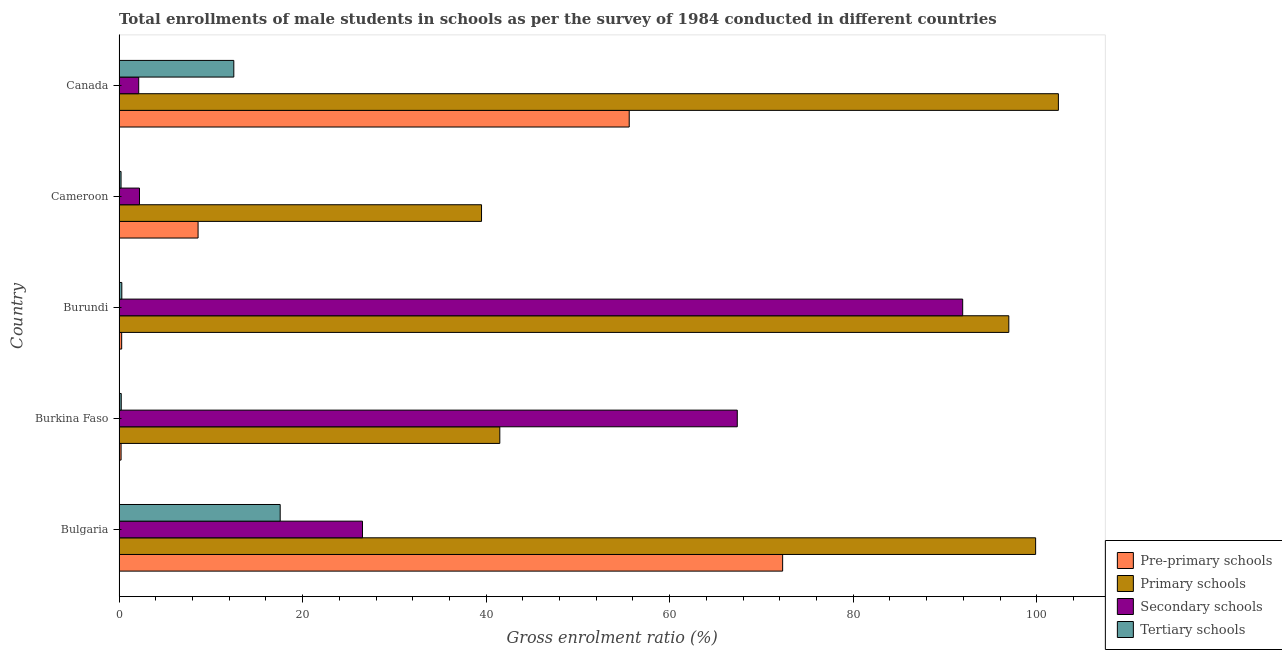How many different coloured bars are there?
Your answer should be very brief. 4. Are the number of bars per tick equal to the number of legend labels?
Provide a short and direct response. Yes. How many bars are there on the 5th tick from the top?
Offer a very short reply. 4. How many bars are there on the 1st tick from the bottom?
Your answer should be compact. 4. What is the label of the 5th group of bars from the top?
Keep it short and to the point. Bulgaria. In how many cases, is the number of bars for a given country not equal to the number of legend labels?
Ensure brevity in your answer.  0. What is the gross enrolment ratio(male) in primary schools in Canada?
Make the answer very short. 102.36. Across all countries, what is the maximum gross enrolment ratio(male) in primary schools?
Make the answer very short. 102.36. Across all countries, what is the minimum gross enrolment ratio(male) in secondary schools?
Offer a terse response. 2.14. In which country was the gross enrolment ratio(male) in pre-primary schools minimum?
Your answer should be very brief. Burkina Faso. What is the total gross enrolment ratio(male) in secondary schools in the graph?
Offer a very short reply. 190.19. What is the difference between the gross enrolment ratio(male) in tertiary schools in Burkina Faso and that in Burundi?
Your answer should be very brief. -0.06. What is the difference between the gross enrolment ratio(male) in pre-primary schools in Burundi and the gross enrolment ratio(male) in primary schools in Burkina Faso?
Keep it short and to the point. -41.2. What is the average gross enrolment ratio(male) in secondary schools per country?
Make the answer very short. 38.04. What is the difference between the gross enrolment ratio(male) in primary schools and gross enrolment ratio(male) in pre-primary schools in Bulgaria?
Make the answer very short. 27.57. In how many countries, is the gross enrolment ratio(male) in tertiary schools greater than 24 %?
Make the answer very short. 0. What is the ratio of the gross enrolment ratio(male) in tertiary schools in Bulgaria to that in Cameroon?
Your answer should be compact. 80.86. What is the difference between the highest and the second highest gross enrolment ratio(male) in tertiary schools?
Provide a succinct answer. 5.05. What is the difference between the highest and the lowest gross enrolment ratio(male) in primary schools?
Your answer should be compact. 62.86. Is the sum of the gross enrolment ratio(male) in pre-primary schools in Bulgaria and Canada greater than the maximum gross enrolment ratio(male) in secondary schools across all countries?
Your answer should be compact. Yes. Is it the case that in every country, the sum of the gross enrolment ratio(male) in tertiary schools and gross enrolment ratio(male) in secondary schools is greater than the sum of gross enrolment ratio(male) in pre-primary schools and gross enrolment ratio(male) in primary schools?
Keep it short and to the point. No. What does the 3rd bar from the top in Cameroon represents?
Ensure brevity in your answer.  Primary schools. What does the 3rd bar from the bottom in Burundi represents?
Provide a short and direct response. Secondary schools. Is it the case that in every country, the sum of the gross enrolment ratio(male) in pre-primary schools and gross enrolment ratio(male) in primary schools is greater than the gross enrolment ratio(male) in secondary schools?
Offer a very short reply. No. How many bars are there?
Make the answer very short. 20. How many countries are there in the graph?
Keep it short and to the point. 5. Are the values on the major ticks of X-axis written in scientific E-notation?
Give a very brief answer. No. How are the legend labels stacked?
Provide a short and direct response. Vertical. What is the title of the graph?
Offer a very short reply. Total enrollments of male students in schools as per the survey of 1984 conducted in different countries. Does "Sweden" appear as one of the legend labels in the graph?
Offer a very short reply. No. What is the label or title of the Y-axis?
Keep it short and to the point. Country. What is the Gross enrolment ratio (%) in Pre-primary schools in Bulgaria?
Your answer should be very brief. 72.31. What is the Gross enrolment ratio (%) in Primary schools in Bulgaria?
Offer a very short reply. 99.88. What is the Gross enrolment ratio (%) in Secondary schools in Bulgaria?
Give a very brief answer. 26.53. What is the Gross enrolment ratio (%) of Tertiary schools in Bulgaria?
Offer a very short reply. 17.56. What is the Gross enrolment ratio (%) in Pre-primary schools in Burkina Faso?
Give a very brief answer. 0.22. What is the Gross enrolment ratio (%) in Primary schools in Burkina Faso?
Offer a terse response. 41.49. What is the Gross enrolment ratio (%) of Secondary schools in Burkina Faso?
Your response must be concise. 67.37. What is the Gross enrolment ratio (%) of Tertiary schools in Burkina Faso?
Keep it short and to the point. 0.24. What is the Gross enrolment ratio (%) in Pre-primary schools in Burundi?
Give a very brief answer. 0.28. What is the Gross enrolment ratio (%) in Primary schools in Burundi?
Ensure brevity in your answer.  96.95. What is the Gross enrolment ratio (%) of Secondary schools in Burundi?
Offer a very short reply. 91.93. What is the Gross enrolment ratio (%) in Tertiary schools in Burundi?
Your response must be concise. 0.3. What is the Gross enrolment ratio (%) of Pre-primary schools in Cameroon?
Offer a very short reply. 8.61. What is the Gross enrolment ratio (%) in Primary schools in Cameroon?
Keep it short and to the point. 39.5. What is the Gross enrolment ratio (%) in Secondary schools in Cameroon?
Offer a terse response. 2.23. What is the Gross enrolment ratio (%) in Tertiary schools in Cameroon?
Your answer should be very brief. 0.22. What is the Gross enrolment ratio (%) of Pre-primary schools in Canada?
Your response must be concise. 55.59. What is the Gross enrolment ratio (%) in Primary schools in Canada?
Your response must be concise. 102.36. What is the Gross enrolment ratio (%) in Secondary schools in Canada?
Offer a terse response. 2.14. What is the Gross enrolment ratio (%) in Tertiary schools in Canada?
Your response must be concise. 12.51. Across all countries, what is the maximum Gross enrolment ratio (%) in Pre-primary schools?
Your answer should be very brief. 72.31. Across all countries, what is the maximum Gross enrolment ratio (%) in Primary schools?
Give a very brief answer. 102.36. Across all countries, what is the maximum Gross enrolment ratio (%) of Secondary schools?
Your answer should be compact. 91.93. Across all countries, what is the maximum Gross enrolment ratio (%) of Tertiary schools?
Offer a very short reply. 17.56. Across all countries, what is the minimum Gross enrolment ratio (%) in Pre-primary schools?
Make the answer very short. 0.22. Across all countries, what is the minimum Gross enrolment ratio (%) in Primary schools?
Keep it short and to the point. 39.5. Across all countries, what is the minimum Gross enrolment ratio (%) of Secondary schools?
Give a very brief answer. 2.14. Across all countries, what is the minimum Gross enrolment ratio (%) in Tertiary schools?
Your answer should be compact. 0.22. What is the total Gross enrolment ratio (%) in Pre-primary schools in the graph?
Keep it short and to the point. 137.02. What is the total Gross enrolment ratio (%) of Primary schools in the graph?
Provide a short and direct response. 380.18. What is the total Gross enrolment ratio (%) of Secondary schools in the graph?
Provide a short and direct response. 190.19. What is the total Gross enrolment ratio (%) of Tertiary schools in the graph?
Ensure brevity in your answer.  30.82. What is the difference between the Gross enrolment ratio (%) of Pre-primary schools in Bulgaria and that in Burkina Faso?
Your response must be concise. 72.09. What is the difference between the Gross enrolment ratio (%) in Primary schools in Bulgaria and that in Burkina Faso?
Provide a short and direct response. 58.39. What is the difference between the Gross enrolment ratio (%) of Secondary schools in Bulgaria and that in Burkina Faso?
Your answer should be compact. -40.84. What is the difference between the Gross enrolment ratio (%) in Tertiary schools in Bulgaria and that in Burkina Faso?
Make the answer very short. 17.32. What is the difference between the Gross enrolment ratio (%) of Pre-primary schools in Bulgaria and that in Burundi?
Your answer should be compact. 72.02. What is the difference between the Gross enrolment ratio (%) of Primary schools in Bulgaria and that in Burundi?
Ensure brevity in your answer.  2.92. What is the difference between the Gross enrolment ratio (%) of Secondary schools in Bulgaria and that in Burundi?
Keep it short and to the point. -65.4. What is the difference between the Gross enrolment ratio (%) of Tertiary schools in Bulgaria and that in Burundi?
Your answer should be compact. 17.26. What is the difference between the Gross enrolment ratio (%) in Pre-primary schools in Bulgaria and that in Cameroon?
Give a very brief answer. 63.7. What is the difference between the Gross enrolment ratio (%) of Primary schools in Bulgaria and that in Cameroon?
Offer a very short reply. 60.38. What is the difference between the Gross enrolment ratio (%) of Secondary schools in Bulgaria and that in Cameroon?
Your answer should be compact. 24.3. What is the difference between the Gross enrolment ratio (%) in Tertiary schools in Bulgaria and that in Cameroon?
Make the answer very short. 17.34. What is the difference between the Gross enrolment ratio (%) in Pre-primary schools in Bulgaria and that in Canada?
Your response must be concise. 16.72. What is the difference between the Gross enrolment ratio (%) of Primary schools in Bulgaria and that in Canada?
Ensure brevity in your answer.  -2.48. What is the difference between the Gross enrolment ratio (%) in Secondary schools in Bulgaria and that in Canada?
Give a very brief answer. 24.38. What is the difference between the Gross enrolment ratio (%) in Tertiary schools in Bulgaria and that in Canada?
Give a very brief answer. 5.05. What is the difference between the Gross enrolment ratio (%) in Pre-primary schools in Burkina Faso and that in Burundi?
Give a very brief answer. -0.06. What is the difference between the Gross enrolment ratio (%) of Primary schools in Burkina Faso and that in Burundi?
Provide a succinct answer. -55.46. What is the difference between the Gross enrolment ratio (%) of Secondary schools in Burkina Faso and that in Burundi?
Ensure brevity in your answer.  -24.56. What is the difference between the Gross enrolment ratio (%) in Tertiary schools in Burkina Faso and that in Burundi?
Ensure brevity in your answer.  -0.06. What is the difference between the Gross enrolment ratio (%) of Pre-primary schools in Burkina Faso and that in Cameroon?
Give a very brief answer. -8.39. What is the difference between the Gross enrolment ratio (%) in Primary schools in Burkina Faso and that in Cameroon?
Provide a short and direct response. 1.99. What is the difference between the Gross enrolment ratio (%) of Secondary schools in Burkina Faso and that in Cameroon?
Keep it short and to the point. 65.14. What is the difference between the Gross enrolment ratio (%) in Tertiary schools in Burkina Faso and that in Cameroon?
Your response must be concise. 0.02. What is the difference between the Gross enrolment ratio (%) of Pre-primary schools in Burkina Faso and that in Canada?
Offer a very short reply. -55.37. What is the difference between the Gross enrolment ratio (%) in Primary schools in Burkina Faso and that in Canada?
Keep it short and to the point. -60.87. What is the difference between the Gross enrolment ratio (%) in Secondary schools in Burkina Faso and that in Canada?
Your response must be concise. 65.22. What is the difference between the Gross enrolment ratio (%) of Tertiary schools in Burkina Faso and that in Canada?
Give a very brief answer. -12.27. What is the difference between the Gross enrolment ratio (%) in Pre-primary schools in Burundi and that in Cameroon?
Make the answer very short. -8.33. What is the difference between the Gross enrolment ratio (%) in Primary schools in Burundi and that in Cameroon?
Your answer should be very brief. 57.45. What is the difference between the Gross enrolment ratio (%) in Secondary schools in Burundi and that in Cameroon?
Give a very brief answer. 89.7. What is the difference between the Gross enrolment ratio (%) in Tertiary schools in Burundi and that in Cameroon?
Ensure brevity in your answer.  0.08. What is the difference between the Gross enrolment ratio (%) of Pre-primary schools in Burundi and that in Canada?
Give a very brief answer. -55.31. What is the difference between the Gross enrolment ratio (%) in Primary schools in Burundi and that in Canada?
Provide a short and direct response. -5.4. What is the difference between the Gross enrolment ratio (%) of Secondary schools in Burundi and that in Canada?
Provide a succinct answer. 89.79. What is the difference between the Gross enrolment ratio (%) in Tertiary schools in Burundi and that in Canada?
Make the answer very short. -12.2. What is the difference between the Gross enrolment ratio (%) of Pre-primary schools in Cameroon and that in Canada?
Provide a short and direct response. -46.98. What is the difference between the Gross enrolment ratio (%) of Primary schools in Cameroon and that in Canada?
Ensure brevity in your answer.  -62.86. What is the difference between the Gross enrolment ratio (%) of Secondary schools in Cameroon and that in Canada?
Give a very brief answer. 0.08. What is the difference between the Gross enrolment ratio (%) in Tertiary schools in Cameroon and that in Canada?
Make the answer very short. -12.29. What is the difference between the Gross enrolment ratio (%) of Pre-primary schools in Bulgaria and the Gross enrolment ratio (%) of Primary schools in Burkina Faso?
Provide a succinct answer. 30.82. What is the difference between the Gross enrolment ratio (%) in Pre-primary schools in Bulgaria and the Gross enrolment ratio (%) in Secondary schools in Burkina Faso?
Ensure brevity in your answer.  4.94. What is the difference between the Gross enrolment ratio (%) of Pre-primary schools in Bulgaria and the Gross enrolment ratio (%) of Tertiary schools in Burkina Faso?
Offer a very short reply. 72.07. What is the difference between the Gross enrolment ratio (%) of Primary schools in Bulgaria and the Gross enrolment ratio (%) of Secondary schools in Burkina Faso?
Offer a terse response. 32.51. What is the difference between the Gross enrolment ratio (%) in Primary schools in Bulgaria and the Gross enrolment ratio (%) in Tertiary schools in Burkina Faso?
Ensure brevity in your answer.  99.64. What is the difference between the Gross enrolment ratio (%) in Secondary schools in Bulgaria and the Gross enrolment ratio (%) in Tertiary schools in Burkina Faso?
Provide a short and direct response. 26.29. What is the difference between the Gross enrolment ratio (%) of Pre-primary schools in Bulgaria and the Gross enrolment ratio (%) of Primary schools in Burundi?
Your response must be concise. -24.64. What is the difference between the Gross enrolment ratio (%) in Pre-primary schools in Bulgaria and the Gross enrolment ratio (%) in Secondary schools in Burundi?
Offer a very short reply. -19.62. What is the difference between the Gross enrolment ratio (%) of Pre-primary schools in Bulgaria and the Gross enrolment ratio (%) of Tertiary schools in Burundi?
Your response must be concise. 72.01. What is the difference between the Gross enrolment ratio (%) in Primary schools in Bulgaria and the Gross enrolment ratio (%) in Secondary schools in Burundi?
Offer a very short reply. 7.95. What is the difference between the Gross enrolment ratio (%) of Primary schools in Bulgaria and the Gross enrolment ratio (%) of Tertiary schools in Burundi?
Provide a succinct answer. 99.58. What is the difference between the Gross enrolment ratio (%) of Secondary schools in Bulgaria and the Gross enrolment ratio (%) of Tertiary schools in Burundi?
Your answer should be very brief. 26.22. What is the difference between the Gross enrolment ratio (%) of Pre-primary schools in Bulgaria and the Gross enrolment ratio (%) of Primary schools in Cameroon?
Make the answer very short. 32.81. What is the difference between the Gross enrolment ratio (%) in Pre-primary schools in Bulgaria and the Gross enrolment ratio (%) in Secondary schools in Cameroon?
Give a very brief answer. 70.08. What is the difference between the Gross enrolment ratio (%) of Pre-primary schools in Bulgaria and the Gross enrolment ratio (%) of Tertiary schools in Cameroon?
Ensure brevity in your answer.  72.09. What is the difference between the Gross enrolment ratio (%) of Primary schools in Bulgaria and the Gross enrolment ratio (%) of Secondary schools in Cameroon?
Ensure brevity in your answer.  97.65. What is the difference between the Gross enrolment ratio (%) of Primary schools in Bulgaria and the Gross enrolment ratio (%) of Tertiary schools in Cameroon?
Give a very brief answer. 99.66. What is the difference between the Gross enrolment ratio (%) in Secondary schools in Bulgaria and the Gross enrolment ratio (%) in Tertiary schools in Cameroon?
Your answer should be very brief. 26.31. What is the difference between the Gross enrolment ratio (%) in Pre-primary schools in Bulgaria and the Gross enrolment ratio (%) in Primary schools in Canada?
Provide a short and direct response. -30.05. What is the difference between the Gross enrolment ratio (%) in Pre-primary schools in Bulgaria and the Gross enrolment ratio (%) in Secondary schools in Canada?
Offer a terse response. 70.17. What is the difference between the Gross enrolment ratio (%) in Pre-primary schools in Bulgaria and the Gross enrolment ratio (%) in Tertiary schools in Canada?
Make the answer very short. 59.8. What is the difference between the Gross enrolment ratio (%) of Primary schools in Bulgaria and the Gross enrolment ratio (%) of Secondary schools in Canada?
Make the answer very short. 97.73. What is the difference between the Gross enrolment ratio (%) in Primary schools in Bulgaria and the Gross enrolment ratio (%) in Tertiary schools in Canada?
Your answer should be compact. 87.37. What is the difference between the Gross enrolment ratio (%) of Secondary schools in Bulgaria and the Gross enrolment ratio (%) of Tertiary schools in Canada?
Your answer should be compact. 14.02. What is the difference between the Gross enrolment ratio (%) of Pre-primary schools in Burkina Faso and the Gross enrolment ratio (%) of Primary schools in Burundi?
Provide a succinct answer. -96.73. What is the difference between the Gross enrolment ratio (%) of Pre-primary schools in Burkina Faso and the Gross enrolment ratio (%) of Secondary schools in Burundi?
Make the answer very short. -91.71. What is the difference between the Gross enrolment ratio (%) in Pre-primary schools in Burkina Faso and the Gross enrolment ratio (%) in Tertiary schools in Burundi?
Keep it short and to the point. -0.08. What is the difference between the Gross enrolment ratio (%) in Primary schools in Burkina Faso and the Gross enrolment ratio (%) in Secondary schools in Burundi?
Offer a terse response. -50.44. What is the difference between the Gross enrolment ratio (%) in Primary schools in Burkina Faso and the Gross enrolment ratio (%) in Tertiary schools in Burundi?
Ensure brevity in your answer.  41.19. What is the difference between the Gross enrolment ratio (%) in Secondary schools in Burkina Faso and the Gross enrolment ratio (%) in Tertiary schools in Burundi?
Offer a very short reply. 67.07. What is the difference between the Gross enrolment ratio (%) in Pre-primary schools in Burkina Faso and the Gross enrolment ratio (%) in Primary schools in Cameroon?
Provide a succinct answer. -39.28. What is the difference between the Gross enrolment ratio (%) of Pre-primary schools in Burkina Faso and the Gross enrolment ratio (%) of Secondary schools in Cameroon?
Your answer should be very brief. -2.01. What is the difference between the Gross enrolment ratio (%) of Pre-primary schools in Burkina Faso and the Gross enrolment ratio (%) of Tertiary schools in Cameroon?
Keep it short and to the point. 0. What is the difference between the Gross enrolment ratio (%) of Primary schools in Burkina Faso and the Gross enrolment ratio (%) of Secondary schools in Cameroon?
Ensure brevity in your answer.  39.26. What is the difference between the Gross enrolment ratio (%) in Primary schools in Burkina Faso and the Gross enrolment ratio (%) in Tertiary schools in Cameroon?
Offer a terse response. 41.27. What is the difference between the Gross enrolment ratio (%) of Secondary schools in Burkina Faso and the Gross enrolment ratio (%) of Tertiary schools in Cameroon?
Keep it short and to the point. 67.15. What is the difference between the Gross enrolment ratio (%) of Pre-primary schools in Burkina Faso and the Gross enrolment ratio (%) of Primary schools in Canada?
Ensure brevity in your answer.  -102.14. What is the difference between the Gross enrolment ratio (%) of Pre-primary schools in Burkina Faso and the Gross enrolment ratio (%) of Secondary schools in Canada?
Make the answer very short. -1.92. What is the difference between the Gross enrolment ratio (%) in Pre-primary schools in Burkina Faso and the Gross enrolment ratio (%) in Tertiary schools in Canada?
Your response must be concise. -12.28. What is the difference between the Gross enrolment ratio (%) in Primary schools in Burkina Faso and the Gross enrolment ratio (%) in Secondary schools in Canada?
Provide a succinct answer. 39.35. What is the difference between the Gross enrolment ratio (%) in Primary schools in Burkina Faso and the Gross enrolment ratio (%) in Tertiary schools in Canada?
Keep it short and to the point. 28.98. What is the difference between the Gross enrolment ratio (%) in Secondary schools in Burkina Faso and the Gross enrolment ratio (%) in Tertiary schools in Canada?
Offer a very short reply. 54.86. What is the difference between the Gross enrolment ratio (%) of Pre-primary schools in Burundi and the Gross enrolment ratio (%) of Primary schools in Cameroon?
Your answer should be compact. -39.21. What is the difference between the Gross enrolment ratio (%) in Pre-primary schools in Burundi and the Gross enrolment ratio (%) in Secondary schools in Cameroon?
Keep it short and to the point. -1.94. What is the difference between the Gross enrolment ratio (%) in Pre-primary schools in Burundi and the Gross enrolment ratio (%) in Tertiary schools in Cameroon?
Provide a short and direct response. 0.07. What is the difference between the Gross enrolment ratio (%) in Primary schools in Burundi and the Gross enrolment ratio (%) in Secondary schools in Cameroon?
Give a very brief answer. 94.73. What is the difference between the Gross enrolment ratio (%) of Primary schools in Burundi and the Gross enrolment ratio (%) of Tertiary schools in Cameroon?
Provide a succinct answer. 96.74. What is the difference between the Gross enrolment ratio (%) of Secondary schools in Burundi and the Gross enrolment ratio (%) of Tertiary schools in Cameroon?
Give a very brief answer. 91.71. What is the difference between the Gross enrolment ratio (%) in Pre-primary schools in Burundi and the Gross enrolment ratio (%) in Primary schools in Canada?
Your response must be concise. -102.07. What is the difference between the Gross enrolment ratio (%) in Pre-primary schools in Burundi and the Gross enrolment ratio (%) in Secondary schools in Canada?
Your answer should be very brief. -1.86. What is the difference between the Gross enrolment ratio (%) in Pre-primary schools in Burundi and the Gross enrolment ratio (%) in Tertiary schools in Canada?
Offer a very short reply. -12.22. What is the difference between the Gross enrolment ratio (%) of Primary schools in Burundi and the Gross enrolment ratio (%) of Secondary schools in Canada?
Offer a terse response. 94.81. What is the difference between the Gross enrolment ratio (%) of Primary schools in Burundi and the Gross enrolment ratio (%) of Tertiary schools in Canada?
Provide a succinct answer. 84.45. What is the difference between the Gross enrolment ratio (%) in Secondary schools in Burundi and the Gross enrolment ratio (%) in Tertiary schools in Canada?
Provide a succinct answer. 79.42. What is the difference between the Gross enrolment ratio (%) of Pre-primary schools in Cameroon and the Gross enrolment ratio (%) of Primary schools in Canada?
Ensure brevity in your answer.  -93.75. What is the difference between the Gross enrolment ratio (%) in Pre-primary schools in Cameroon and the Gross enrolment ratio (%) in Secondary schools in Canada?
Your answer should be very brief. 6.47. What is the difference between the Gross enrolment ratio (%) in Pre-primary schools in Cameroon and the Gross enrolment ratio (%) in Tertiary schools in Canada?
Provide a short and direct response. -3.89. What is the difference between the Gross enrolment ratio (%) in Primary schools in Cameroon and the Gross enrolment ratio (%) in Secondary schools in Canada?
Ensure brevity in your answer.  37.36. What is the difference between the Gross enrolment ratio (%) in Primary schools in Cameroon and the Gross enrolment ratio (%) in Tertiary schools in Canada?
Give a very brief answer. 26.99. What is the difference between the Gross enrolment ratio (%) of Secondary schools in Cameroon and the Gross enrolment ratio (%) of Tertiary schools in Canada?
Ensure brevity in your answer.  -10.28. What is the average Gross enrolment ratio (%) in Pre-primary schools per country?
Your answer should be compact. 27.4. What is the average Gross enrolment ratio (%) of Primary schools per country?
Your response must be concise. 76.04. What is the average Gross enrolment ratio (%) in Secondary schools per country?
Your answer should be compact. 38.04. What is the average Gross enrolment ratio (%) in Tertiary schools per country?
Your answer should be very brief. 6.16. What is the difference between the Gross enrolment ratio (%) in Pre-primary schools and Gross enrolment ratio (%) in Primary schools in Bulgaria?
Offer a terse response. -27.57. What is the difference between the Gross enrolment ratio (%) of Pre-primary schools and Gross enrolment ratio (%) of Secondary schools in Bulgaria?
Your answer should be very brief. 45.78. What is the difference between the Gross enrolment ratio (%) in Pre-primary schools and Gross enrolment ratio (%) in Tertiary schools in Bulgaria?
Provide a succinct answer. 54.75. What is the difference between the Gross enrolment ratio (%) in Primary schools and Gross enrolment ratio (%) in Secondary schools in Bulgaria?
Your response must be concise. 73.35. What is the difference between the Gross enrolment ratio (%) in Primary schools and Gross enrolment ratio (%) in Tertiary schools in Bulgaria?
Offer a terse response. 82.32. What is the difference between the Gross enrolment ratio (%) in Secondary schools and Gross enrolment ratio (%) in Tertiary schools in Bulgaria?
Ensure brevity in your answer.  8.97. What is the difference between the Gross enrolment ratio (%) of Pre-primary schools and Gross enrolment ratio (%) of Primary schools in Burkina Faso?
Ensure brevity in your answer.  -41.27. What is the difference between the Gross enrolment ratio (%) in Pre-primary schools and Gross enrolment ratio (%) in Secondary schools in Burkina Faso?
Provide a short and direct response. -67.15. What is the difference between the Gross enrolment ratio (%) in Pre-primary schools and Gross enrolment ratio (%) in Tertiary schools in Burkina Faso?
Provide a short and direct response. -0.02. What is the difference between the Gross enrolment ratio (%) in Primary schools and Gross enrolment ratio (%) in Secondary schools in Burkina Faso?
Offer a very short reply. -25.88. What is the difference between the Gross enrolment ratio (%) of Primary schools and Gross enrolment ratio (%) of Tertiary schools in Burkina Faso?
Provide a succinct answer. 41.25. What is the difference between the Gross enrolment ratio (%) in Secondary schools and Gross enrolment ratio (%) in Tertiary schools in Burkina Faso?
Your answer should be compact. 67.13. What is the difference between the Gross enrolment ratio (%) of Pre-primary schools and Gross enrolment ratio (%) of Primary schools in Burundi?
Give a very brief answer. -96.67. What is the difference between the Gross enrolment ratio (%) in Pre-primary schools and Gross enrolment ratio (%) in Secondary schools in Burundi?
Your answer should be very brief. -91.64. What is the difference between the Gross enrolment ratio (%) of Pre-primary schools and Gross enrolment ratio (%) of Tertiary schools in Burundi?
Your response must be concise. -0.02. What is the difference between the Gross enrolment ratio (%) in Primary schools and Gross enrolment ratio (%) in Secondary schools in Burundi?
Offer a very short reply. 5.02. What is the difference between the Gross enrolment ratio (%) in Primary schools and Gross enrolment ratio (%) in Tertiary schools in Burundi?
Your answer should be very brief. 96.65. What is the difference between the Gross enrolment ratio (%) in Secondary schools and Gross enrolment ratio (%) in Tertiary schools in Burundi?
Offer a very short reply. 91.63. What is the difference between the Gross enrolment ratio (%) in Pre-primary schools and Gross enrolment ratio (%) in Primary schools in Cameroon?
Keep it short and to the point. -30.89. What is the difference between the Gross enrolment ratio (%) of Pre-primary schools and Gross enrolment ratio (%) of Secondary schools in Cameroon?
Offer a terse response. 6.38. What is the difference between the Gross enrolment ratio (%) in Pre-primary schools and Gross enrolment ratio (%) in Tertiary schools in Cameroon?
Your response must be concise. 8.39. What is the difference between the Gross enrolment ratio (%) of Primary schools and Gross enrolment ratio (%) of Secondary schools in Cameroon?
Give a very brief answer. 37.27. What is the difference between the Gross enrolment ratio (%) in Primary schools and Gross enrolment ratio (%) in Tertiary schools in Cameroon?
Your answer should be compact. 39.28. What is the difference between the Gross enrolment ratio (%) in Secondary schools and Gross enrolment ratio (%) in Tertiary schools in Cameroon?
Your answer should be very brief. 2.01. What is the difference between the Gross enrolment ratio (%) in Pre-primary schools and Gross enrolment ratio (%) in Primary schools in Canada?
Make the answer very short. -46.77. What is the difference between the Gross enrolment ratio (%) in Pre-primary schools and Gross enrolment ratio (%) in Secondary schools in Canada?
Offer a terse response. 53.45. What is the difference between the Gross enrolment ratio (%) in Pre-primary schools and Gross enrolment ratio (%) in Tertiary schools in Canada?
Provide a succinct answer. 43.08. What is the difference between the Gross enrolment ratio (%) of Primary schools and Gross enrolment ratio (%) of Secondary schools in Canada?
Your answer should be compact. 100.21. What is the difference between the Gross enrolment ratio (%) of Primary schools and Gross enrolment ratio (%) of Tertiary schools in Canada?
Ensure brevity in your answer.  89.85. What is the difference between the Gross enrolment ratio (%) in Secondary schools and Gross enrolment ratio (%) in Tertiary schools in Canada?
Your answer should be very brief. -10.36. What is the ratio of the Gross enrolment ratio (%) of Pre-primary schools in Bulgaria to that in Burkina Faso?
Provide a short and direct response. 326.59. What is the ratio of the Gross enrolment ratio (%) in Primary schools in Bulgaria to that in Burkina Faso?
Give a very brief answer. 2.41. What is the ratio of the Gross enrolment ratio (%) of Secondary schools in Bulgaria to that in Burkina Faso?
Make the answer very short. 0.39. What is the ratio of the Gross enrolment ratio (%) of Tertiary schools in Bulgaria to that in Burkina Faso?
Make the answer very short. 73.68. What is the ratio of the Gross enrolment ratio (%) of Pre-primary schools in Bulgaria to that in Burundi?
Make the answer very short. 253.74. What is the ratio of the Gross enrolment ratio (%) of Primary schools in Bulgaria to that in Burundi?
Offer a terse response. 1.03. What is the ratio of the Gross enrolment ratio (%) of Secondary schools in Bulgaria to that in Burundi?
Provide a short and direct response. 0.29. What is the ratio of the Gross enrolment ratio (%) in Tertiary schools in Bulgaria to that in Burundi?
Provide a short and direct response. 58.34. What is the ratio of the Gross enrolment ratio (%) in Pre-primary schools in Bulgaria to that in Cameroon?
Your answer should be compact. 8.4. What is the ratio of the Gross enrolment ratio (%) of Primary schools in Bulgaria to that in Cameroon?
Give a very brief answer. 2.53. What is the ratio of the Gross enrolment ratio (%) in Secondary schools in Bulgaria to that in Cameroon?
Provide a short and direct response. 11.91. What is the ratio of the Gross enrolment ratio (%) of Tertiary schools in Bulgaria to that in Cameroon?
Offer a terse response. 80.86. What is the ratio of the Gross enrolment ratio (%) of Pre-primary schools in Bulgaria to that in Canada?
Ensure brevity in your answer.  1.3. What is the ratio of the Gross enrolment ratio (%) in Primary schools in Bulgaria to that in Canada?
Provide a short and direct response. 0.98. What is the ratio of the Gross enrolment ratio (%) in Secondary schools in Bulgaria to that in Canada?
Offer a very short reply. 12.38. What is the ratio of the Gross enrolment ratio (%) in Tertiary schools in Bulgaria to that in Canada?
Your answer should be compact. 1.4. What is the ratio of the Gross enrolment ratio (%) in Pre-primary schools in Burkina Faso to that in Burundi?
Ensure brevity in your answer.  0.78. What is the ratio of the Gross enrolment ratio (%) in Primary schools in Burkina Faso to that in Burundi?
Provide a short and direct response. 0.43. What is the ratio of the Gross enrolment ratio (%) in Secondary schools in Burkina Faso to that in Burundi?
Provide a succinct answer. 0.73. What is the ratio of the Gross enrolment ratio (%) of Tertiary schools in Burkina Faso to that in Burundi?
Offer a terse response. 0.79. What is the ratio of the Gross enrolment ratio (%) in Pre-primary schools in Burkina Faso to that in Cameroon?
Provide a succinct answer. 0.03. What is the ratio of the Gross enrolment ratio (%) in Primary schools in Burkina Faso to that in Cameroon?
Offer a very short reply. 1.05. What is the ratio of the Gross enrolment ratio (%) in Secondary schools in Burkina Faso to that in Cameroon?
Keep it short and to the point. 30.26. What is the ratio of the Gross enrolment ratio (%) of Tertiary schools in Burkina Faso to that in Cameroon?
Provide a short and direct response. 1.1. What is the ratio of the Gross enrolment ratio (%) of Pre-primary schools in Burkina Faso to that in Canada?
Offer a very short reply. 0. What is the ratio of the Gross enrolment ratio (%) of Primary schools in Burkina Faso to that in Canada?
Offer a terse response. 0.41. What is the ratio of the Gross enrolment ratio (%) of Secondary schools in Burkina Faso to that in Canada?
Give a very brief answer. 31.44. What is the ratio of the Gross enrolment ratio (%) in Tertiary schools in Burkina Faso to that in Canada?
Provide a succinct answer. 0.02. What is the ratio of the Gross enrolment ratio (%) in Pre-primary schools in Burundi to that in Cameroon?
Provide a succinct answer. 0.03. What is the ratio of the Gross enrolment ratio (%) of Primary schools in Burundi to that in Cameroon?
Offer a terse response. 2.45. What is the ratio of the Gross enrolment ratio (%) in Secondary schools in Burundi to that in Cameroon?
Provide a short and direct response. 41.29. What is the ratio of the Gross enrolment ratio (%) of Tertiary schools in Burundi to that in Cameroon?
Ensure brevity in your answer.  1.39. What is the ratio of the Gross enrolment ratio (%) of Pre-primary schools in Burundi to that in Canada?
Your response must be concise. 0.01. What is the ratio of the Gross enrolment ratio (%) of Primary schools in Burundi to that in Canada?
Provide a succinct answer. 0.95. What is the ratio of the Gross enrolment ratio (%) of Secondary schools in Burundi to that in Canada?
Provide a succinct answer. 42.9. What is the ratio of the Gross enrolment ratio (%) in Tertiary schools in Burundi to that in Canada?
Provide a succinct answer. 0.02. What is the ratio of the Gross enrolment ratio (%) of Pre-primary schools in Cameroon to that in Canada?
Provide a succinct answer. 0.15. What is the ratio of the Gross enrolment ratio (%) in Primary schools in Cameroon to that in Canada?
Offer a very short reply. 0.39. What is the ratio of the Gross enrolment ratio (%) in Secondary schools in Cameroon to that in Canada?
Offer a very short reply. 1.04. What is the ratio of the Gross enrolment ratio (%) in Tertiary schools in Cameroon to that in Canada?
Give a very brief answer. 0.02. What is the difference between the highest and the second highest Gross enrolment ratio (%) in Pre-primary schools?
Provide a short and direct response. 16.72. What is the difference between the highest and the second highest Gross enrolment ratio (%) of Primary schools?
Offer a very short reply. 2.48. What is the difference between the highest and the second highest Gross enrolment ratio (%) in Secondary schools?
Keep it short and to the point. 24.56. What is the difference between the highest and the second highest Gross enrolment ratio (%) of Tertiary schools?
Your response must be concise. 5.05. What is the difference between the highest and the lowest Gross enrolment ratio (%) in Pre-primary schools?
Offer a very short reply. 72.09. What is the difference between the highest and the lowest Gross enrolment ratio (%) of Primary schools?
Your response must be concise. 62.86. What is the difference between the highest and the lowest Gross enrolment ratio (%) in Secondary schools?
Your answer should be compact. 89.79. What is the difference between the highest and the lowest Gross enrolment ratio (%) of Tertiary schools?
Provide a succinct answer. 17.34. 